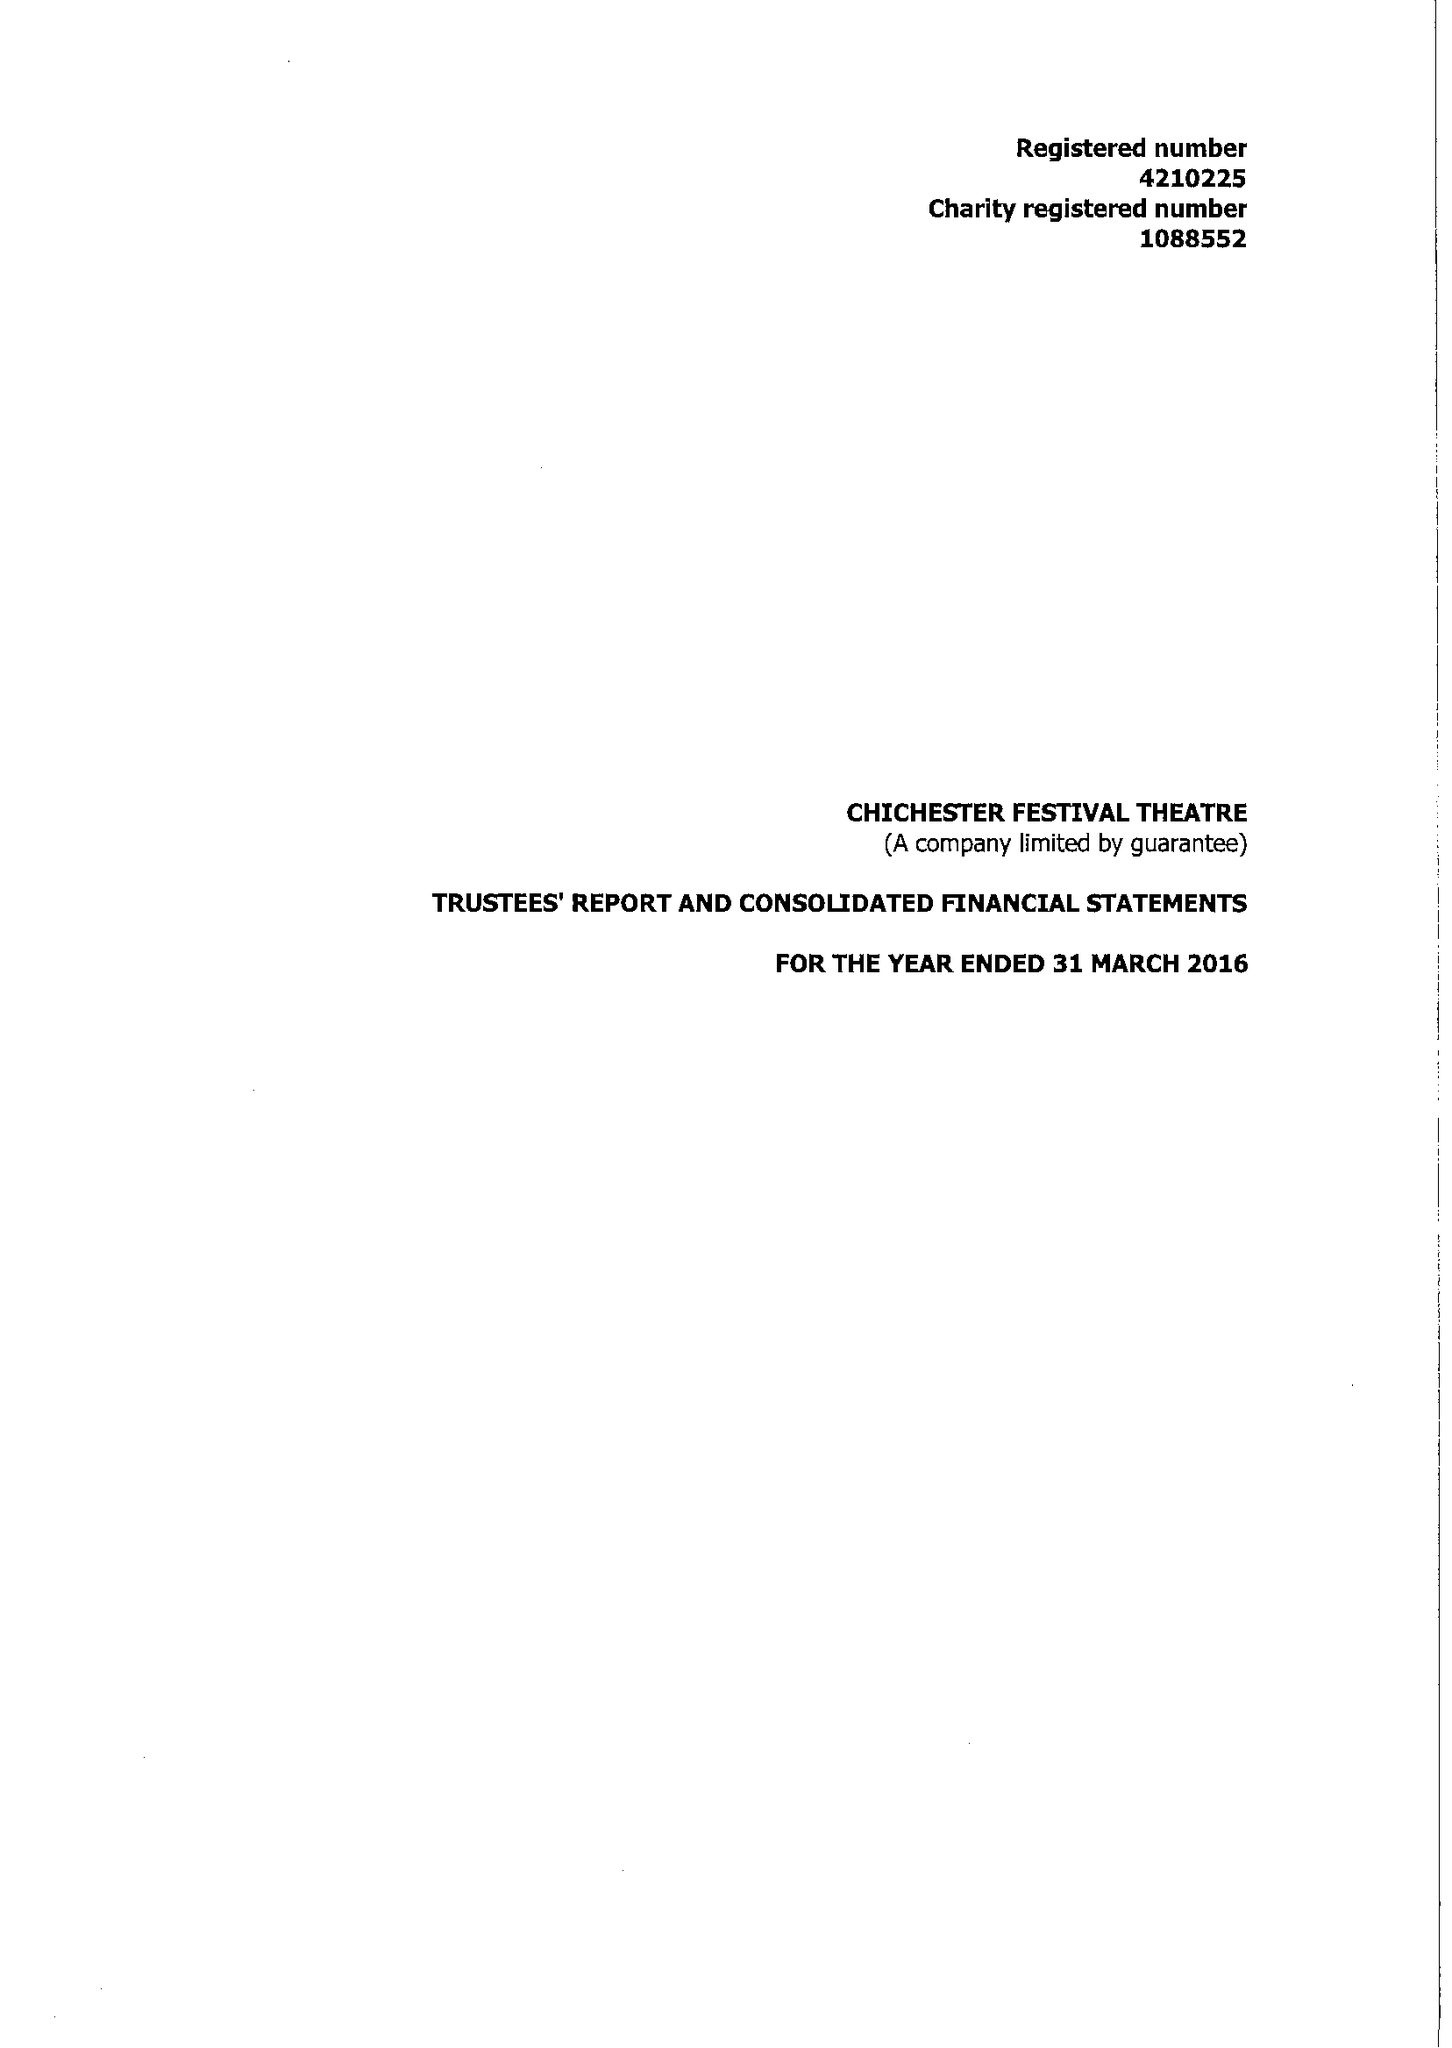What is the value for the address__post_town?
Answer the question using a single word or phrase. CHICHESTER 